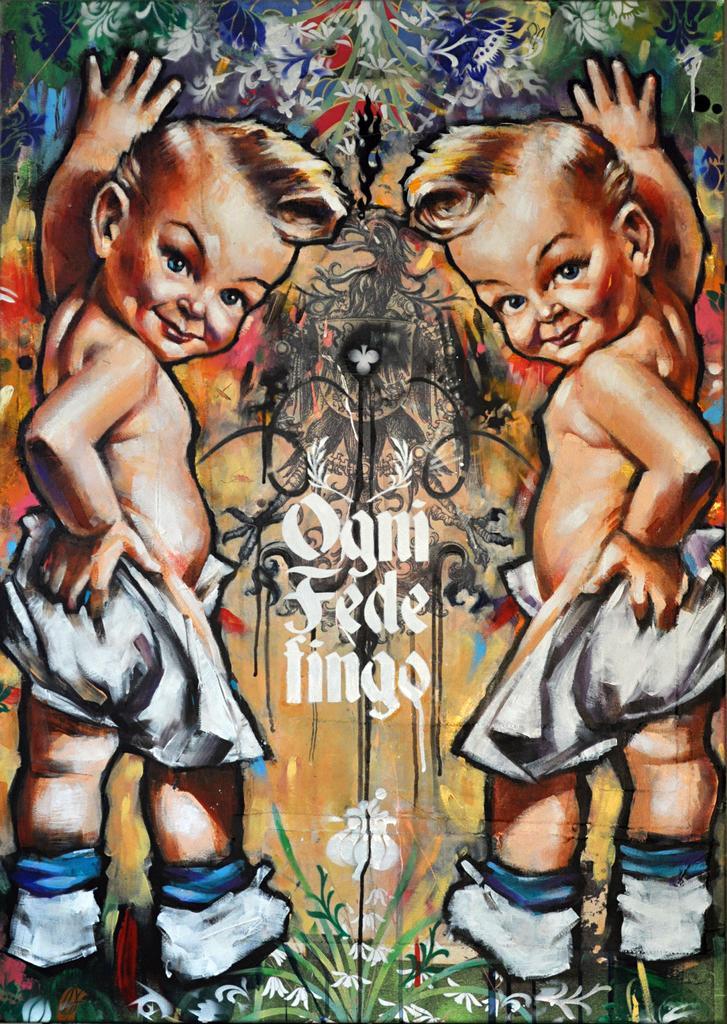What is the main subject of the image? There is a painting in the image. What does the painting depict? The painting depicts two babies. What are the babies doing in the painting? The babies are standing over a place. Is there any text present in the painting? Yes, there is text written in the middle of the painting. What type of attraction can be seen in the background of the painting? There is no attraction visible in the background of the painting; it only depicts two babies standing over a place. What kind of engine is powering the babies in the painting? The painting does not depict any engines or mechanisms powering the babies; they are simply standing over a place. 